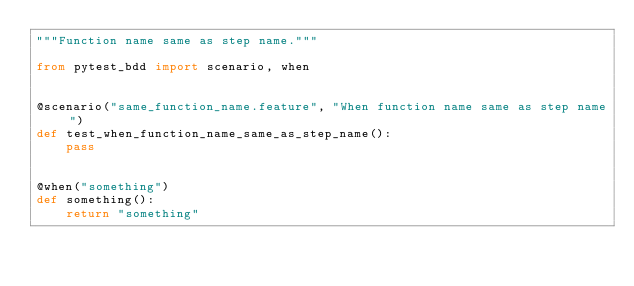<code> <loc_0><loc_0><loc_500><loc_500><_Python_>"""Function name same as step name."""

from pytest_bdd import scenario, when


@scenario("same_function_name.feature", "When function name same as step name")
def test_when_function_name_same_as_step_name():
    pass


@when("something")
def something():
    return "something"
</code> 